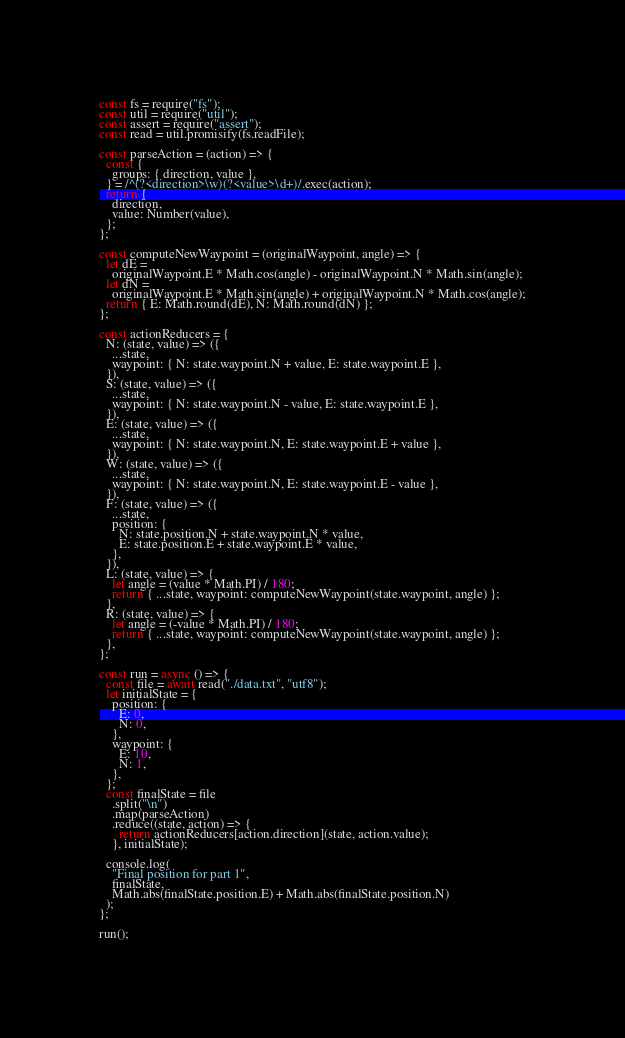<code> <loc_0><loc_0><loc_500><loc_500><_JavaScript_>const fs = require("fs");
const util = require("util");
const assert = require("assert");
const read = util.promisify(fs.readFile);

const parseAction = (action) => {
  const {
    groups: { direction, value },
  } = /^(?<direction>\w)(?<value>\d+)/.exec(action);
  return {
    direction,
    value: Number(value),
  };
};

const computeNewWaypoint = (originalWaypoint, angle) => {
  let dE =
    originalWaypoint.E * Math.cos(angle) - originalWaypoint.N * Math.sin(angle);
  let dN =
    originalWaypoint.E * Math.sin(angle) + originalWaypoint.N * Math.cos(angle);
  return { E: Math.round(dE), N: Math.round(dN) };
};

const actionReducers = {
  N: (state, value) => ({
    ...state,
    waypoint: { N: state.waypoint.N + value, E: state.waypoint.E },
  }),
  S: (state, value) => ({
    ...state,
    waypoint: { N: state.waypoint.N - value, E: state.waypoint.E },
  }),
  E: (state, value) => ({
    ...state,
    waypoint: { N: state.waypoint.N, E: state.waypoint.E + value },
  }),
  W: (state, value) => ({
    ...state,
    waypoint: { N: state.waypoint.N, E: state.waypoint.E - value },
  }),
  F: (state, value) => ({
    ...state,
    position: {
      N: state.position.N + state.waypoint.N * value,
      E: state.position.E + state.waypoint.E * value,
    },
  }),
  L: (state, value) => {
    let angle = (value * Math.PI) / 180;
    return { ...state, waypoint: computeNewWaypoint(state.waypoint, angle) };
  },
  R: (state, value) => {
    let angle = (-value * Math.PI) / 180;
    return { ...state, waypoint: computeNewWaypoint(state.waypoint, angle) };
  },
};

const run = async () => {
  const file = await read("./data.txt", "utf8");
  let initialState = {
    position: {
      E: 0,
      N: 0,
    },
    waypoint: {
      E: 10,
      N: 1,
    },
  };
  const finalState = file
    .split("\n")
    .map(parseAction)
    .reduce((state, action) => {
      return actionReducers[action.direction](state, action.value);
    }, initialState);

  console.log(
    "Final position for part 1",
    finalState,
    Math.abs(finalState.position.E) + Math.abs(finalState.position.N)
  );
};

run();
</code> 